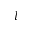<formula> <loc_0><loc_0><loc_500><loc_500>l</formula> 